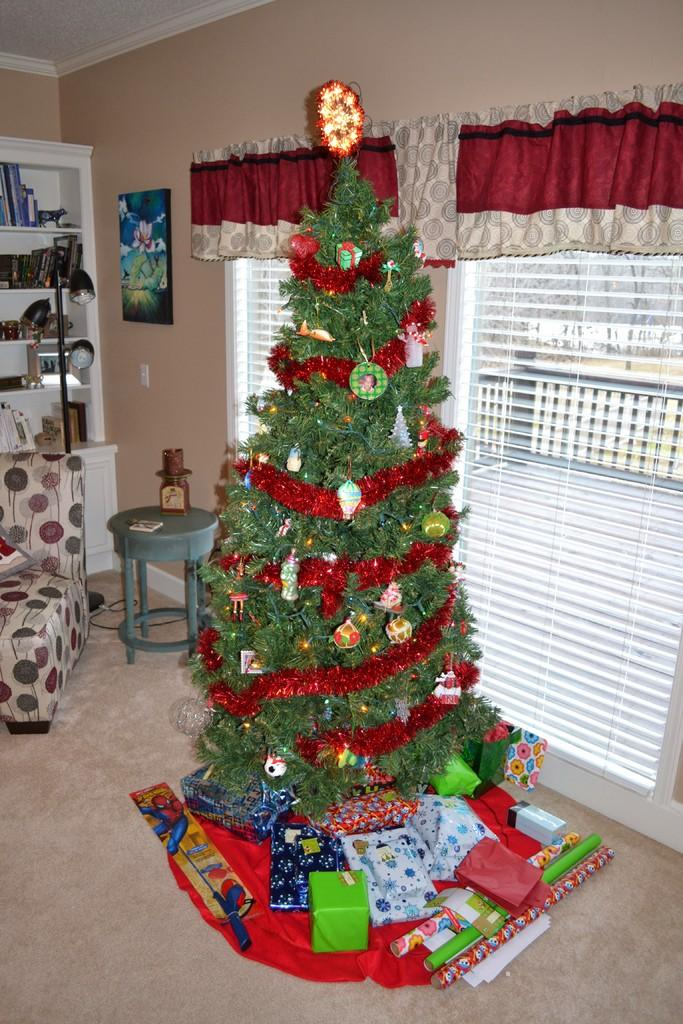What type of tree is in the image? There is a Christmas tree in the image. What can be seen on the windows in the image? The windows have curtains in the image. What is on the rack in the image? There is a rack with books in the image. What is the light attached to in the image? The light has a pole in the image. What type of seating is in the image? There is a couch in the image. What type of furniture is in the image for placing items? There is a table in the image. What is hanging on the wall in the image? There is a picture on a wall in the image. What is placed in front of the Christmas tree in the image? There are gifts in front of the tree in the image. What type of quilt is being used to jump over in the image? There is no quilt or jumping activity present in the image. 